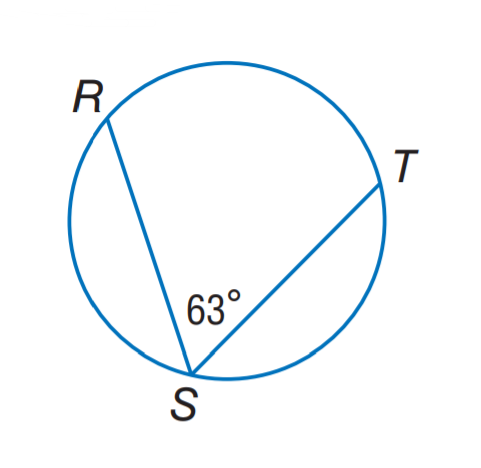Answer the mathemtical geometry problem and directly provide the correct option letter.
Question: Find m \widehat R T.
Choices: A: 54 B: 63 C: 108 D: 126 D 